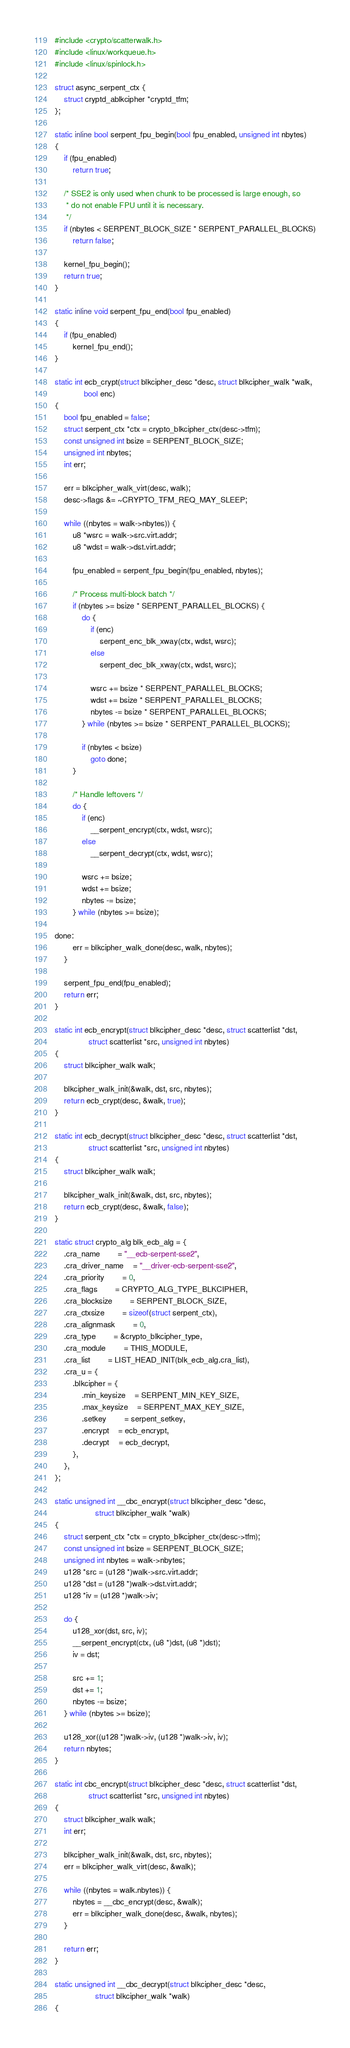<code> <loc_0><loc_0><loc_500><loc_500><_C_>#include <crypto/scatterwalk.h>
#include <linux/workqueue.h>
#include <linux/spinlock.h>

struct async_serpent_ctx {
	struct cryptd_ablkcipher *cryptd_tfm;
};

static inline bool serpent_fpu_begin(bool fpu_enabled, unsigned int nbytes)
{
	if (fpu_enabled)
		return true;

	/* SSE2 is only used when chunk to be processed is large enough, so
	 * do not enable FPU until it is necessary.
	 */
	if (nbytes < SERPENT_BLOCK_SIZE * SERPENT_PARALLEL_BLOCKS)
		return false;

	kernel_fpu_begin();
	return true;
}

static inline void serpent_fpu_end(bool fpu_enabled)
{
	if (fpu_enabled)
		kernel_fpu_end();
}

static int ecb_crypt(struct blkcipher_desc *desc, struct blkcipher_walk *walk,
		     bool enc)
{
	bool fpu_enabled = false;
	struct serpent_ctx *ctx = crypto_blkcipher_ctx(desc->tfm);
	const unsigned int bsize = SERPENT_BLOCK_SIZE;
	unsigned int nbytes;
	int err;

	err = blkcipher_walk_virt(desc, walk);
	desc->flags &= ~CRYPTO_TFM_REQ_MAY_SLEEP;

	while ((nbytes = walk->nbytes)) {
		u8 *wsrc = walk->src.virt.addr;
		u8 *wdst = walk->dst.virt.addr;

		fpu_enabled = serpent_fpu_begin(fpu_enabled, nbytes);

		/* Process multi-block batch */
		if (nbytes >= bsize * SERPENT_PARALLEL_BLOCKS) {
			do {
				if (enc)
					serpent_enc_blk_xway(ctx, wdst, wsrc);
				else
					serpent_dec_blk_xway(ctx, wdst, wsrc);

				wsrc += bsize * SERPENT_PARALLEL_BLOCKS;
				wdst += bsize * SERPENT_PARALLEL_BLOCKS;
				nbytes -= bsize * SERPENT_PARALLEL_BLOCKS;
			} while (nbytes >= bsize * SERPENT_PARALLEL_BLOCKS);

			if (nbytes < bsize)
				goto done;
		}

		/* Handle leftovers */
		do {
			if (enc)
				__serpent_encrypt(ctx, wdst, wsrc);
			else
				__serpent_decrypt(ctx, wdst, wsrc);

			wsrc += bsize;
			wdst += bsize;
			nbytes -= bsize;
		} while (nbytes >= bsize);

done:
		err = blkcipher_walk_done(desc, walk, nbytes);
	}

	serpent_fpu_end(fpu_enabled);
	return err;
}

static int ecb_encrypt(struct blkcipher_desc *desc, struct scatterlist *dst,
		       struct scatterlist *src, unsigned int nbytes)
{
	struct blkcipher_walk walk;

	blkcipher_walk_init(&walk, dst, src, nbytes);
	return ecb_crypt(desc, &walk, true);
}

static int ecb_decrypt(struct blkcipher_desc *desc, struct scatterlist *dst,
		       struct scatterlist *src, unsigned int nbytes)
{
	struct blkcipher_walk walk;

	blkcipher_walk_init(&walk, dst, src, nbytes);
	return ecb_crypt(desc, &walk, false);
}

static struct crypto_alg blk_ecb_alg = {
	.cra_name		= "__ecb-serpent-sse2",
	.cra_driver_name	= "__driver-ecb-serpent-sse2",
	.cra_priority		= 0,
	.cra_flags		= CRYPTO_ALG_TYPE_BLKCIPHER,
	.cra_blocksize		= SERPENT_BLOCK_SIZE,
	.cra_ctxsize		= sizeof(struct serpent_ctx),
	.cra_alignmask		= 0,
	.cra_type		= &crypto_blkcipher_type,
	.cra_module		= THIS_MODULE,
	.cra_list		= LIST_HEAD_INIT(blk_ecb_alg.cra_list),
	.cra_u = {
		.blkcipher = {
			.min_keysize	= SERPENT_MIN_KEY_SIZE,
			.max_keysize	= SERPENT_MAX_KEY_SIZE,
			.setkey		= serpent_setkey,
			.encrypt	= ecb_encrypt,
			.decrypt	= ecb_decrypt,
		},
	},
};

static unsigned int __cbc_encrypt(struct blkcipher_desc *desc,
				  struct blkcipher_walk *walk)
{
	struct serpent_ctx *ctx = crypto_blkcipher_ctx(desc->tfm);
	const unsigned int bsize = SERPENT_BLOCK_SIZE;
	unsigned int nbytes = walk->nbytes;
	u128 *src = (u128 *)walk->src.virt.addr;
	u128 *dst = (u128 *)walk->dst.virt.addr;
	u128 *iv = (u128 *)walk->iv;

	do {
		u128_xor(dst, src, iv);
		__serpent_encrypt(ctx, (u8 *)dst, (u8 *)dst);
		iv = dst;

		src += 1;
		dst += 1;
		nbytes -= bsize;
	} while (nbytes >= bsize);

	u128_xor((u128 *)walk->iv, (u128 *)walk->iv, iv);
	return nbytes;
}

static int cbc_encrypt(struct blkcipher_desc *desc, struct scatterlist *dst,
		       struct scatterlist *src, unsigned int nbytes)
{
	struct blkcipher_walk walk;
	int err;

	blkcipher_walk_init(&walk, dst, src, nbytes);
	err = blkcipher_walk_virt(desc, &walk);

	while ((nbytes = walk.nbytes)) {
		nbytes = __cbc_encrypt(desc, &walk);
		err = blkcipher_walk_done(desc, &walk, nbytes);
	}

	return err;
}

static unsigned int __cbc_decrypt(struct blkcipher_desc *desc,
				  struct blkcipher_walk *walk)
{</code> 